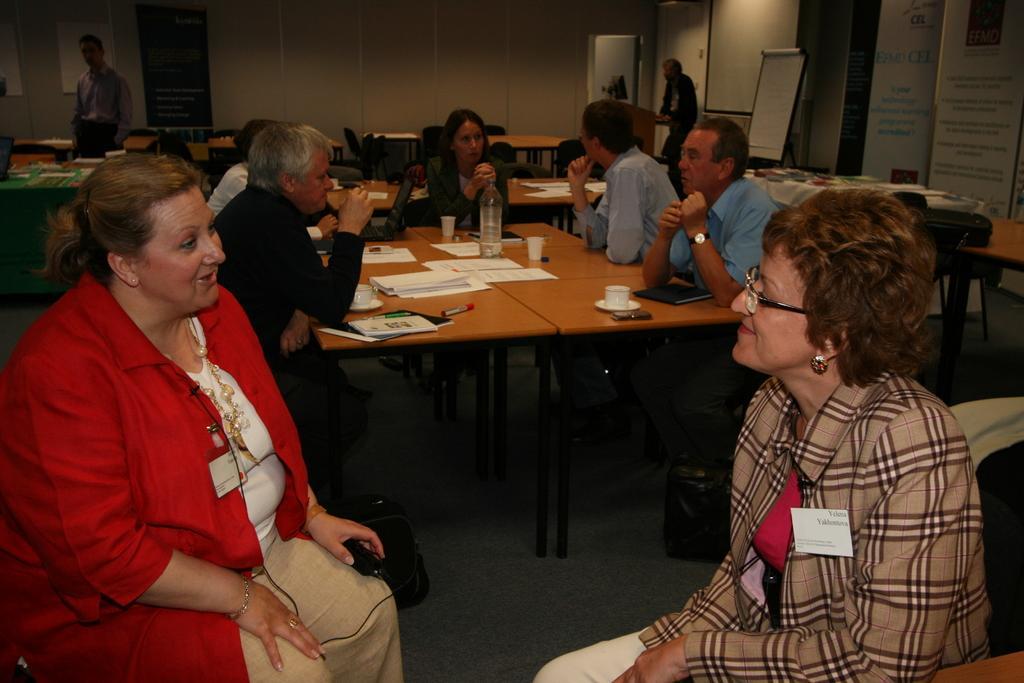Could you give a brief overview of what you see in this image? This image is clicked in a room. There are many people in this image. In the middle, there is a table on which there are papers, glasses and bottles. To the left, the woman sitting is wearing a red jacket. To the right, the woman sitting is wearing a brown suit. In the background there is a wall, posters and boards. 